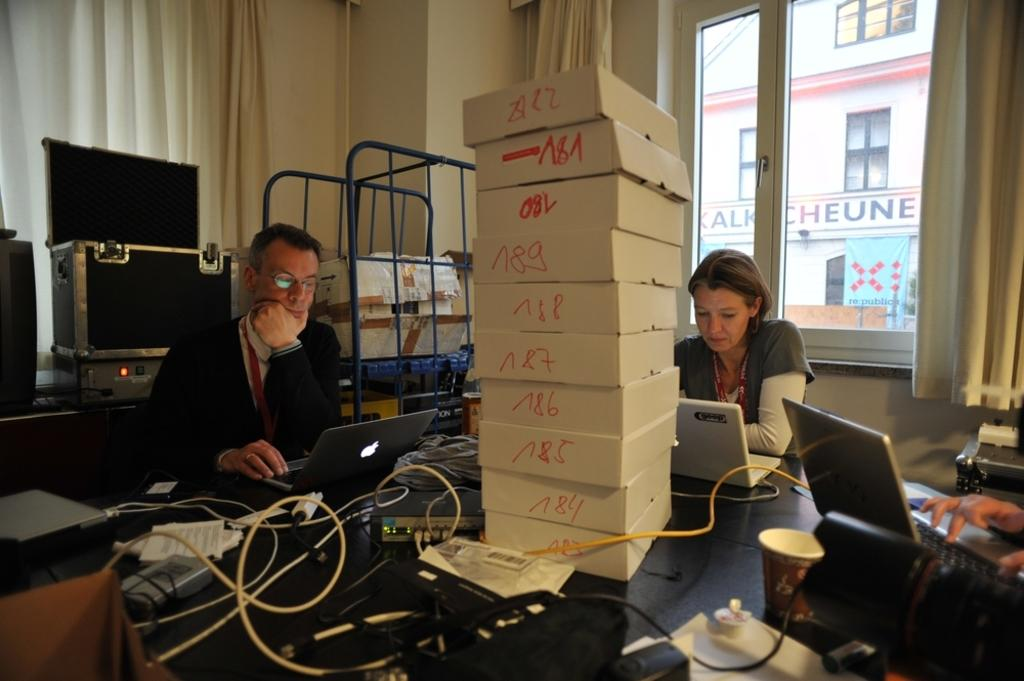<image>
Give a short and clear explanation of the subsequent image. Woman working on a laptop behind some boxes with one saying AZZ on top. 